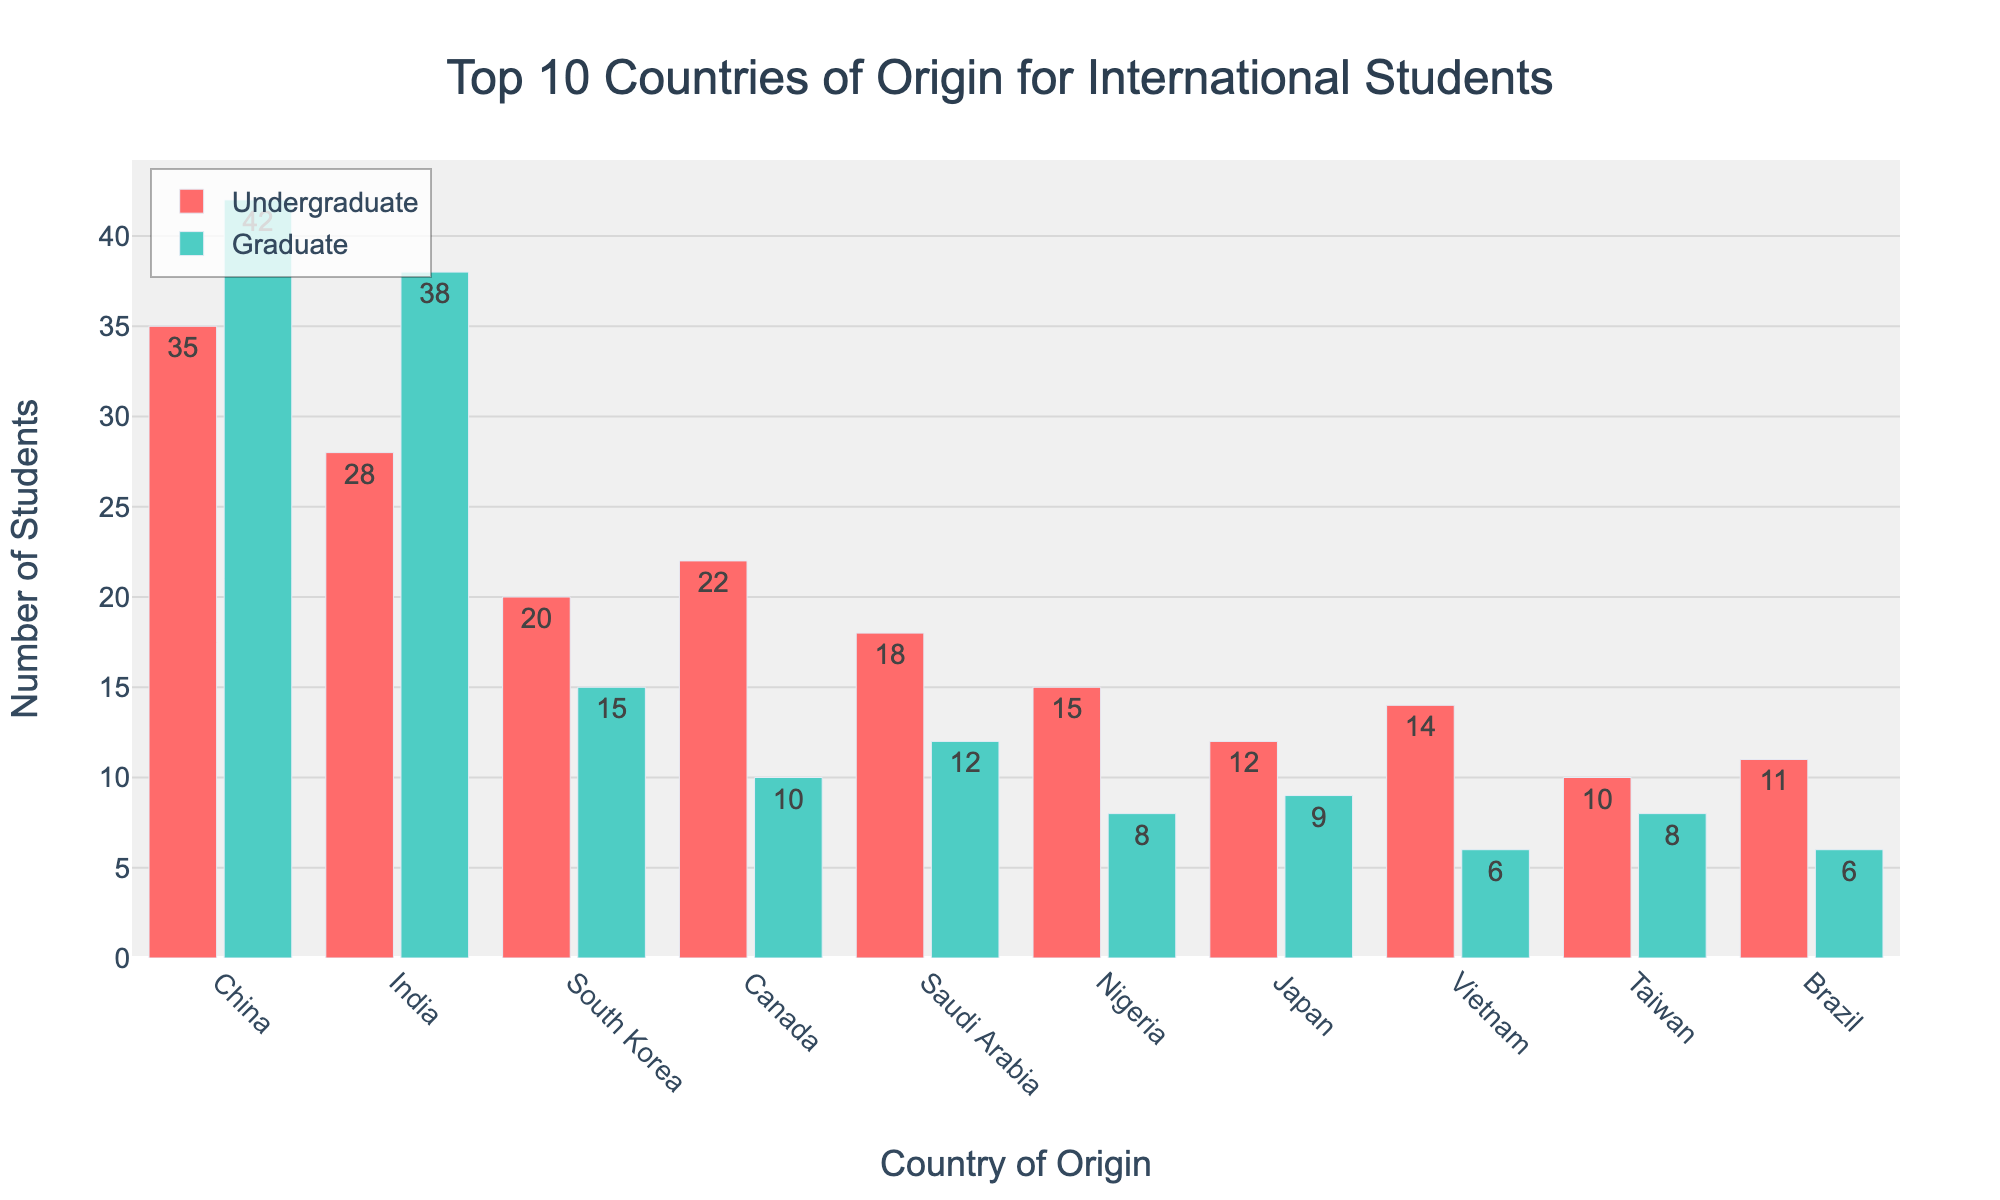What's the title of the plot? The title is displayed prominently at the top of the figure. It reads "Top 10 Countries of Origin for International Students".
Answer: Top 10 Countries of Origin for International Students Which country has the highest number of total students? By looking at the stacked bars, China has the longest combined bar for undergraduate and graduate students, indicating it has the highest total.
Answer: China How many undergraduate students are there from India? The red bar for India represents undergraduate students, and it shows the number 28 on top.
Answer: 28 How many graduate students are from South Korea? The green bar for South Korea indicates graduate students, and the number on top of the bar is 15.
Answer: 15 What is the total number of students from Saudi Arabia? The sum of the undergraduate and graduate numbers for Saudi Arabia (18 undergraduates + 12 graduates) gives the total number.
Answer: 30 What is the combined number of undergraduate students from Japan and Canada? The undergraduate numbers for Canada and Japan are 22 and 12, respectively, so the combined number is 22 + 12.
Answer: 34 Which country has more graduate students, Vietnam or Taiwan? Comparing the green bars, Vietnam has 6 graduate students, while Taiwan has 8 graduate students.
Answer: Taiwan What is the difference in total students between Brazil and Germany? Germany has 16 total students and Brazil has 17. The difference is 17 - 16.
Answer: 1 Which country has nearly an equal number of undergraduate and graduate students? Taiwan has 10 undergraduate and 8 graduate students, which are close in numbers.
Answer: Taiwan How many countries have more than 20 total students? The countries with more than 20 total students, based on their total bar lengths, are China, India, South Korea, Saudi Arabia, and Canada.
Answer: 5 